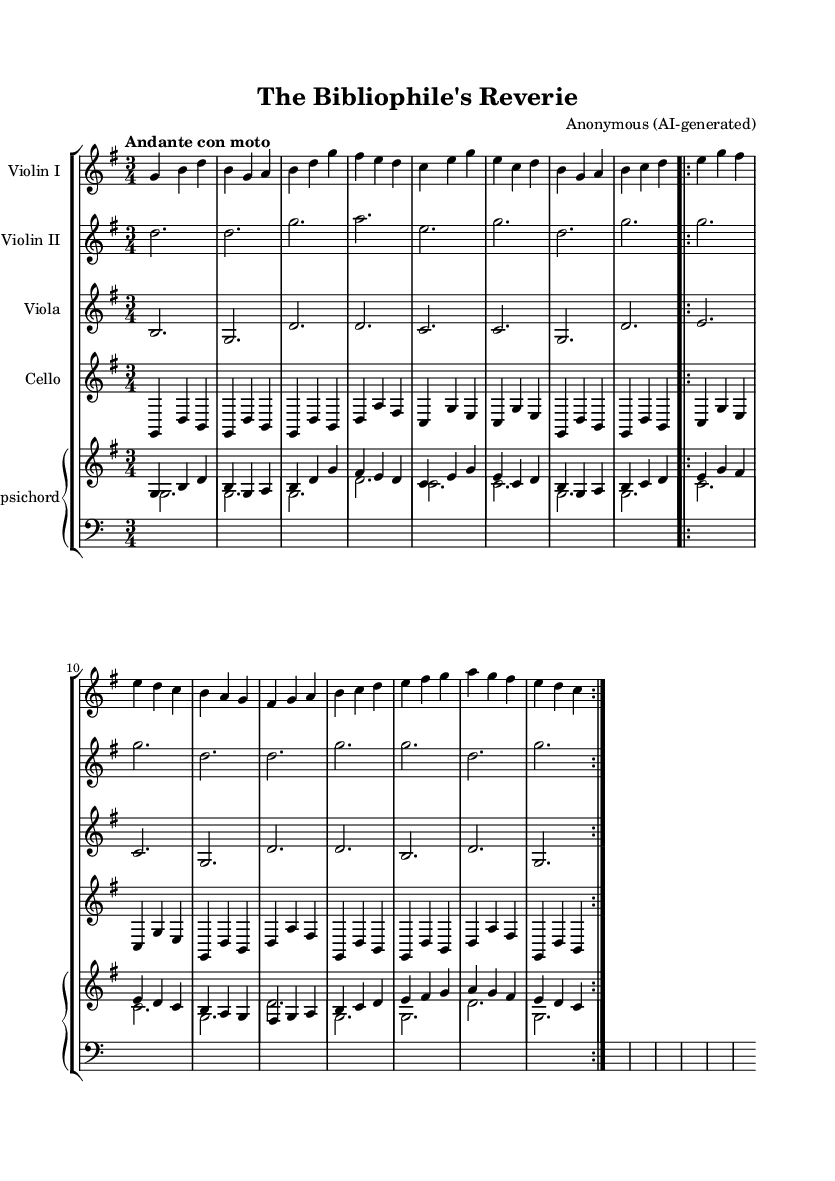What is the key signature of this music? The key signature is G major, which has one sharp (F#) indicated at the beginning of the staff.
Answer: G major What is the time signature of this music? The time signature is 3/4, shown at the beginning of the score, which means there are three beats in each measure.
Answer: 3/4 What is the tempo marking of this piece? The tempo marking is "Andante con moto," which suggests a moderately slow tempo with some movement.
Answer: Andante con moto How many measures are there in the first section? The first section has 8 measures, as counted from the beginning to the first repeat sign indicating the end of that section.
Answer: 8 What instrument plays the melodic line primarily? The violin I part primarily carries the melodic line throughout the piece, evident from the leading notes in the score.
Answer: Violin I How many times is the section repeated in this score? The score indicates a repeat of the section twice, as shown by the repeat volta signs at the end of the two sections.
Answer: 2 What type of musical form is prominent in this piece? The musical form is a binary structure, where the first section is repeated, often common in Baroque orchestral suites.
Answer: Binary 